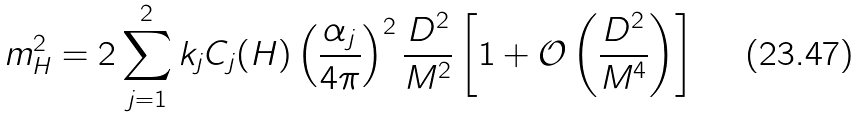Convert formula to latex. <formula><loc_0><loc_0><loc_500><loc_500>m _ { H } ^ { 2 } = 2 \sum _ { j = 1 } ^ { 2 } k _ { j } C _ { j } ( H ) \left ( \frac { \alpha _ { j } } { 4 \pi } \right ) ^ { 2 } \frac { D ^ { 2 } } { M ^ { 2 } } \left [ 1 + \mathcal { O } \left ( \frac { D ^ { 2 } } { M ^ { 4 } } \right ) \right ]</formula> 